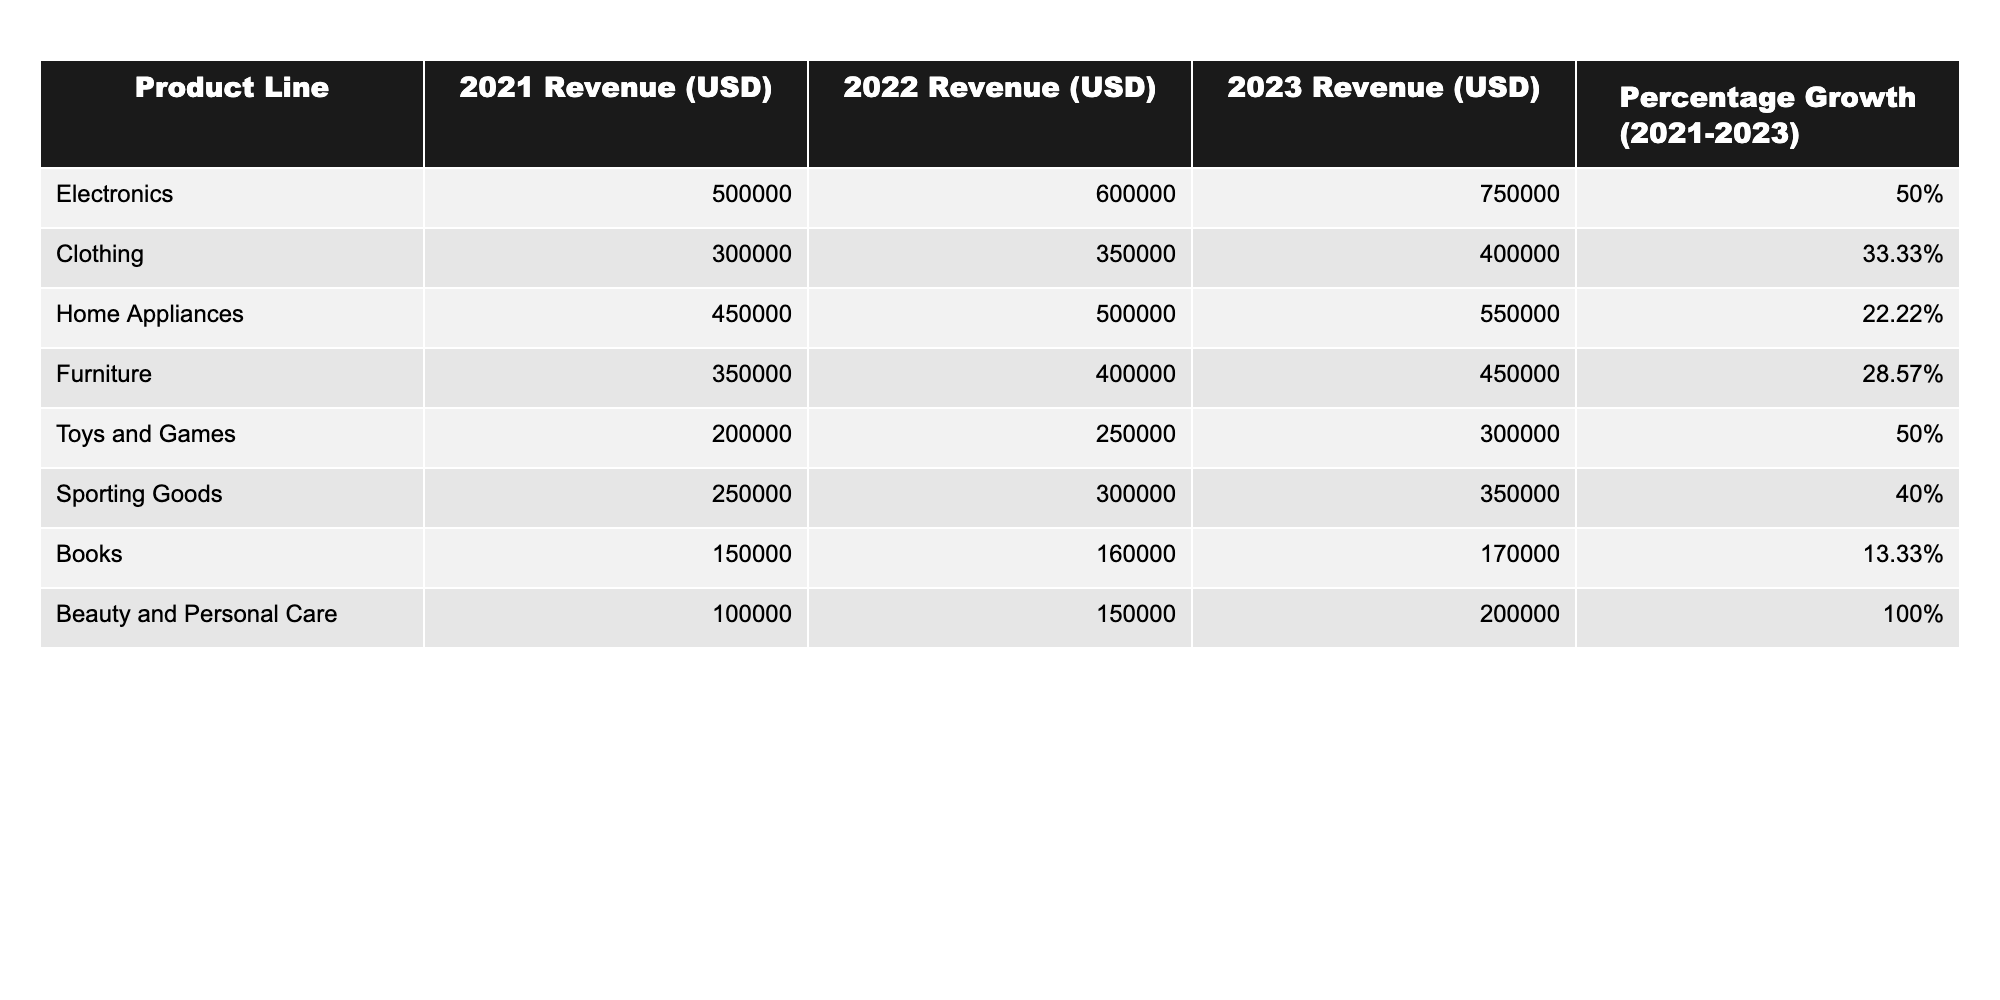What was the total revenue for Electronics in 2022? The table shows that the revenue for Electronics in 2022 is 600,000 USD.
Answer: 600,000 USD Which product line had the highest percentage growth from 2021 to 2023? In the table, Beauty and Personal Care has a percentage growth of 100%, which is the highest among all product lines.
Answer: Beauty and Personal Care What is the difference in revenue for Furniture between 2021 and 2023? The revenue for Furniture in 2023 is 450,000 USD, and in 2021 it was 350,000 USD. The difference is 450,000 - 350,000 = 100,000 USD.
Answer: 100,000 USD What is the average revenue for all product lines in 2022? To calculate the average revenue for 2022, add the revenues: 600,000 + 350,000 + 500,000 + 400,000 + 250,000 + 300,000 + 160,000 + 150,000 = 2,310,000 USD. There are 8 product lines, so the average is 2,310,000 / 8 = 288,750 USD.
Answer: 288,750 USD Did the revenue for Books increase every year from 2021 to 2023? The table shows that the revenue for Books in 2021 was 150,000 USD, 160,000 USD in 2022, and 170,000 USD in 2023, indicating that the revenue increased every year.
Answer: Yes What is the total percentage growth for Sporting Goods from 2021 to 2023? The percentage growth for Sporting Goods from 2021 to 2023 is provided in the table as 40%.
Answer: 40% Which product line had the lowest revenue in 2021? According to the table, books had the lowest revenue in 2021 at 150,000 USD.
Answer: Books If you combine the revenue of Clothing and Home Appliances for 2022, how much would that total? The revenue for Clothing in 2022 is 350,000 USD and for Home Appliances is 500,000 USD. The total is 350,000 + 500,000 = 850,000 USD.
Answer: 850,000 USD What is the revenue trend for Toys and Games from 2021 to 2023? The revenue for Toys and Games increased from 200,000 USD in 2021 to 250,000 USD in 2022 and further to 300,000 USD in 2023, indicating a positive trend.
Answer: Positive trend Which product line had a revenue of 550,000 USD in 2023? The table indicates that Home Appliances had a revenue of 550,000 USD in 2023.
Answer: Home Appliances 